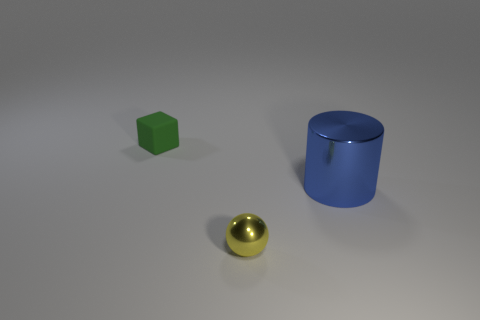Are there any blocks that have the same material as the large blue object?
Offer a very short reply. No. How many objects are either things behind the metal sphere or large blue cylinders?
Keep it short and to the point. 2. Is there a big blue thing?
Ensure brevity in your answer.  Yes. The object that is both behind the small yellow metallic sphere and to the left of the big shiny object has what shape?
Make the answer very short. Cube. What is the size of the object that is behind the big blue shiny object?
Offer a very short reply. Small. There is a small object in front of the large cylinder; is it the same color as the matte cube?
Offer a very short reply. No. What number of big blue metal objects have the same shape as the tiny yellow thing?
Your response must be concise. 0. What number of objects are either tiny matte objects left of the big blue thing or metallic objects right of the small yellow metal ball?
Give a very brief answer. 2. How many yellow objects are either cylinders or rubber cubes?
Offer a terse response. 0. There is a thing that is both behind the small metal ball and to the left of the large shiny cylinder; what material is it?
Provide a succinct answer. Rubber. 